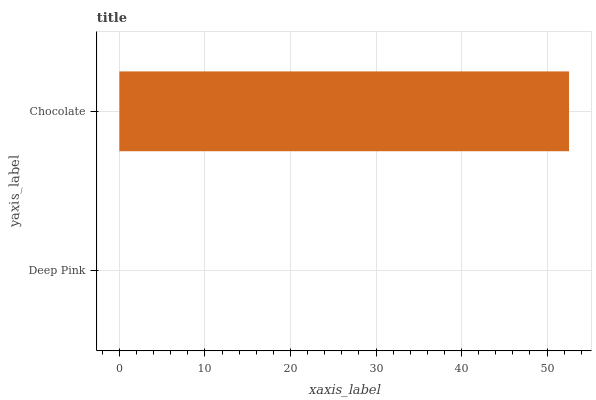Is Deep Pink the minimum?
Answer yes or no. Yes. Is Chocolate the maximum?
Answer yes or no. Yes. Is Chocolate the minimum?
Answer yes or no. No. Is Chocolate greater than Deep Pink?
Answer yes or no. Yes. Is Deep Pink less than Chocolate?
Answer yes or no. Yes. Is Deep Pink greater than Chocolate?
Answer yes or no. No. Is Chocolate less than Deep Pink?
Answer yes or no. No. Is Chocolate the high median?
Answer yes or no. Yes. Is Deep Pink the low median?
Answer yes or no. Yes. Is Deep Pink the high median?
Answer yes or no. No. Is Chocolate the low median?
Answer yes or no. No. 